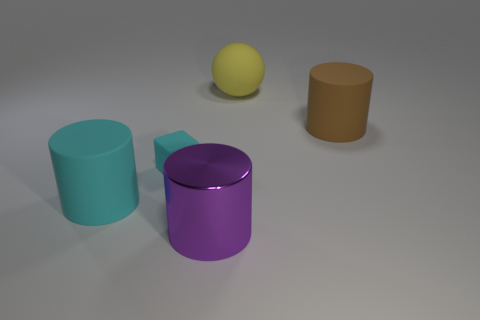Does the large metal object have the same shape as the small cyan matte thing?
Your answer should be very brief. No. What is the size of the rubber ball?
Offer a terse response. Large. How many purple metallic cylinders have the same size as the brown cylinder?
Make the answer very short. 1. There is a cyan rubber object in front of the tiny thing; does it have the same size as the rubber block that is left of the brown rubber cylinder?
Provide a short and direct response. No. There is a big thing that is to the left of the small matte cube; what is its shape?
Offer a very short reply. Cylinder. The object that is behind the matte cylinder right of the large shiny cylinder is made of what material?
Offer a terse response. Rubber. Is there a big rubber object that has the same color as the small thing?
Give a very brief answer. Yes. Is the size of the yellow object the same as the rubber cylinder to the right of the big cyan object?
Provide a short and direct response. Yes. There is a big object behind the big rubber cylinder behind the large cyan cylinder; what number of large brown objects are on the right side of it?
Provide a short and direct response. 1. What number of brown cylinders are left of the big purple object?
Your answer should be very brief. 0. 